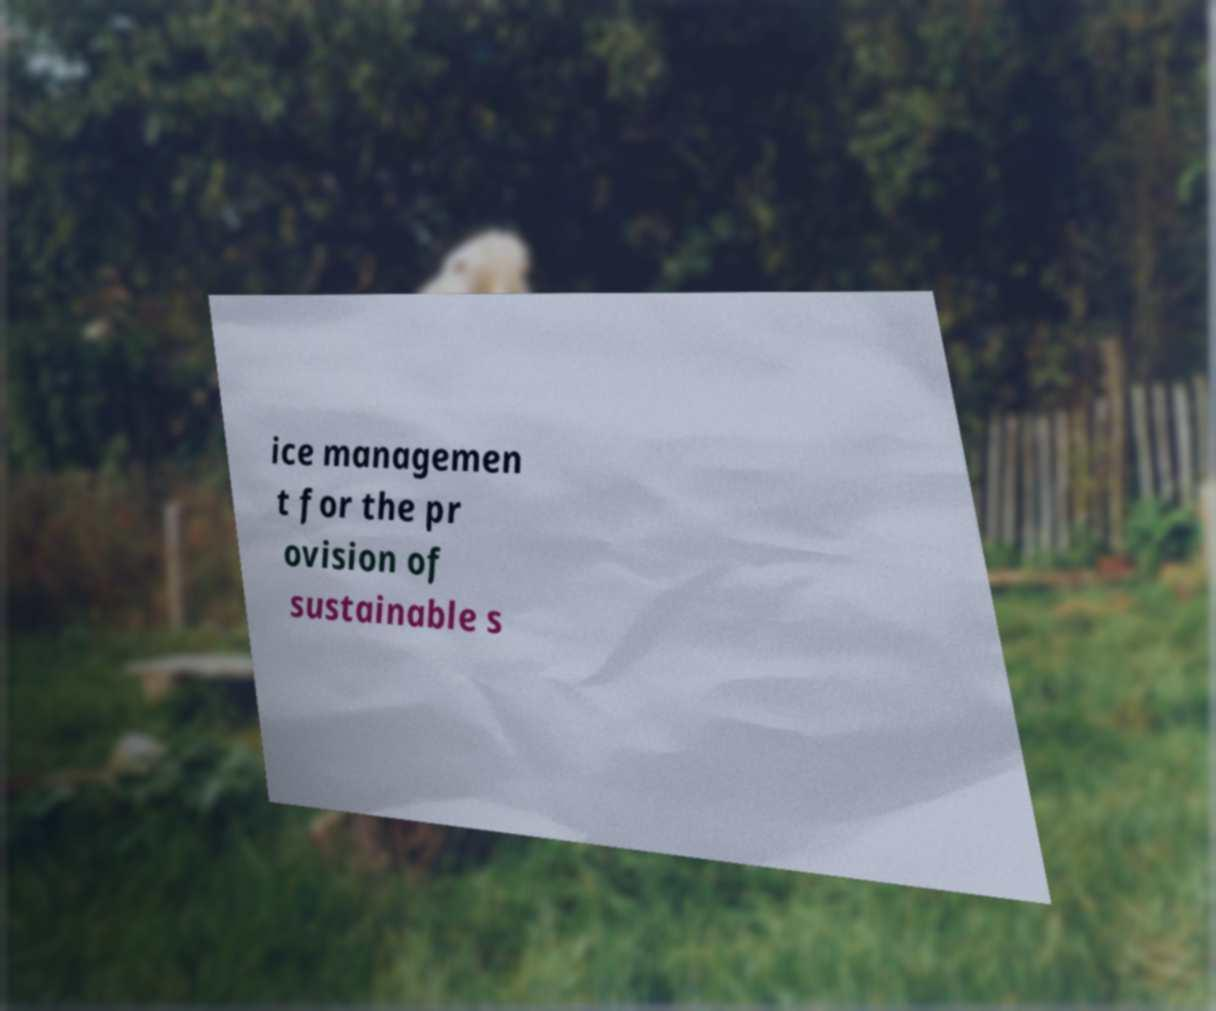Please identify and transcribe the text found in this image. ice managemen t for the pr ovision of sustainable s 